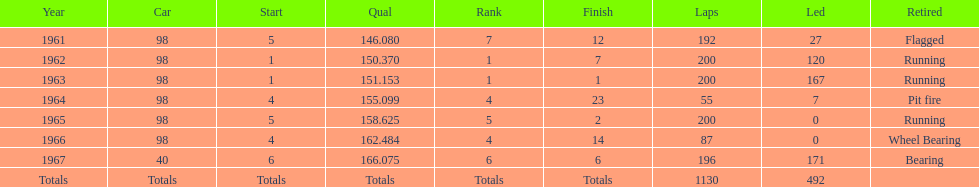How many times must one complete the races while running? 3. 